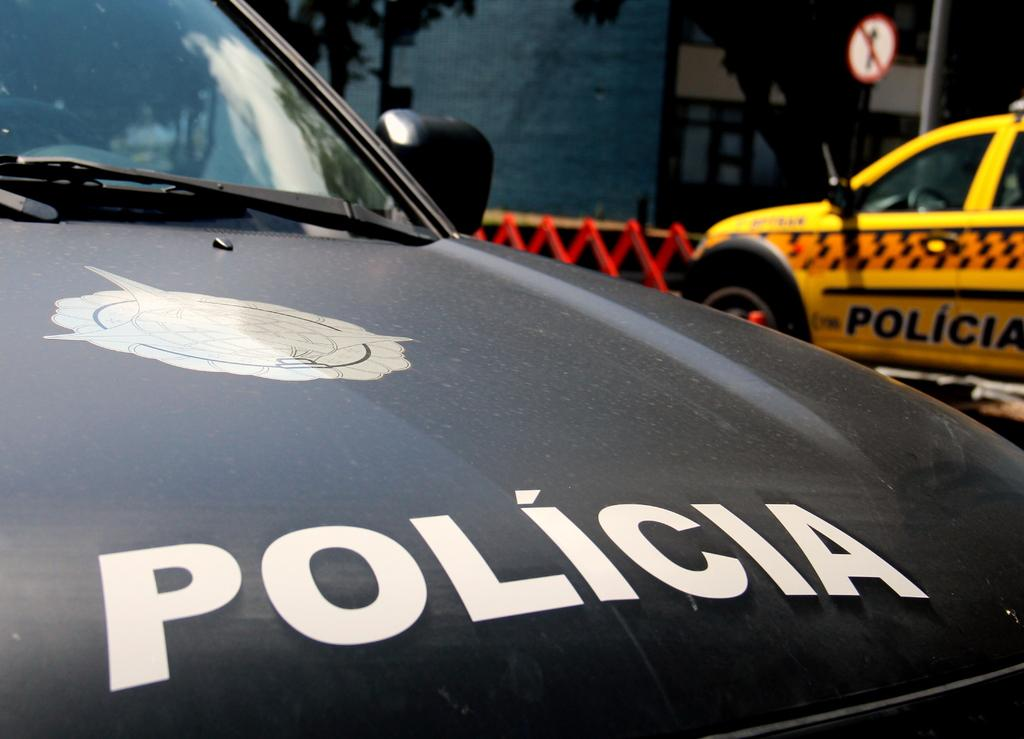Provide a one-sentence caption for the provided image. Parked black police car with the word "Policia" on the hood. 